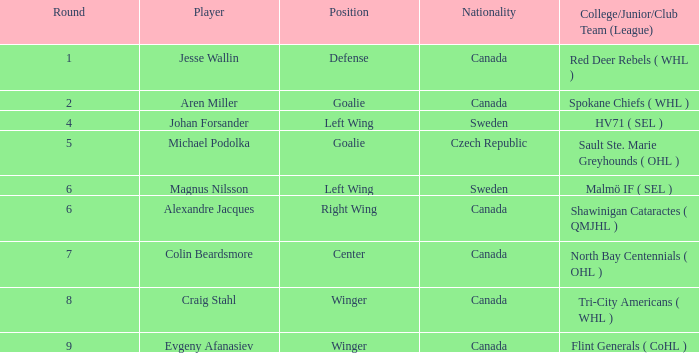What is the Nationality for alexandre jacques? Canada. 